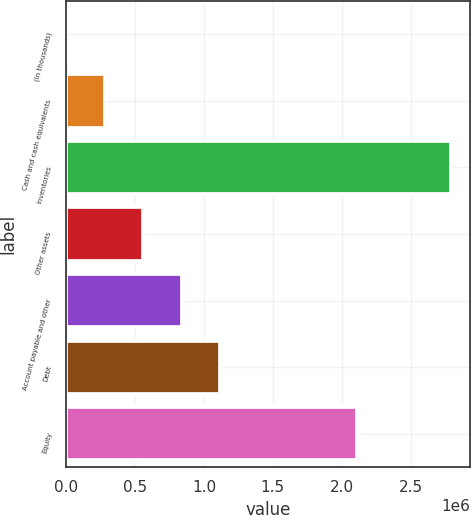Convert chart. <chart><loc_0><loc_0><loc_500><loc_500><bar_chart><fcel>(In thousands)<fcel>Cash and cash equivalents<fcel>Inventories<fcel>Other assets<fcel>Account payable and other<fcel>Debt<fcel>Equity<nl><fcel>2012<fcel>281017<fcel>2.79206e+06<fcel>560022<fcel>839028<fcel>1.11803e+06<fcel>2.11117e+06<nl></chart> 